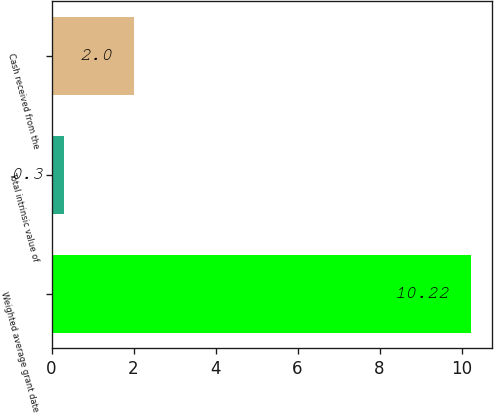Convert chart. <chart><loc_0><loc_0><loc_500><loc_500><bar_chart><fcel>Weighted average grant date<fcel>Total intrinsic value of<fcel>Cash received from the<nl><fcel>10.22<fcel>0.3<fcel>2<nl></chart> 